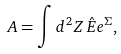<formula> <loc_0><loc_0><loc_500><loc_500>A = \int d ^ { 2 } Z \, \hat { E } e ^ { \Sigma } ,</formula> 